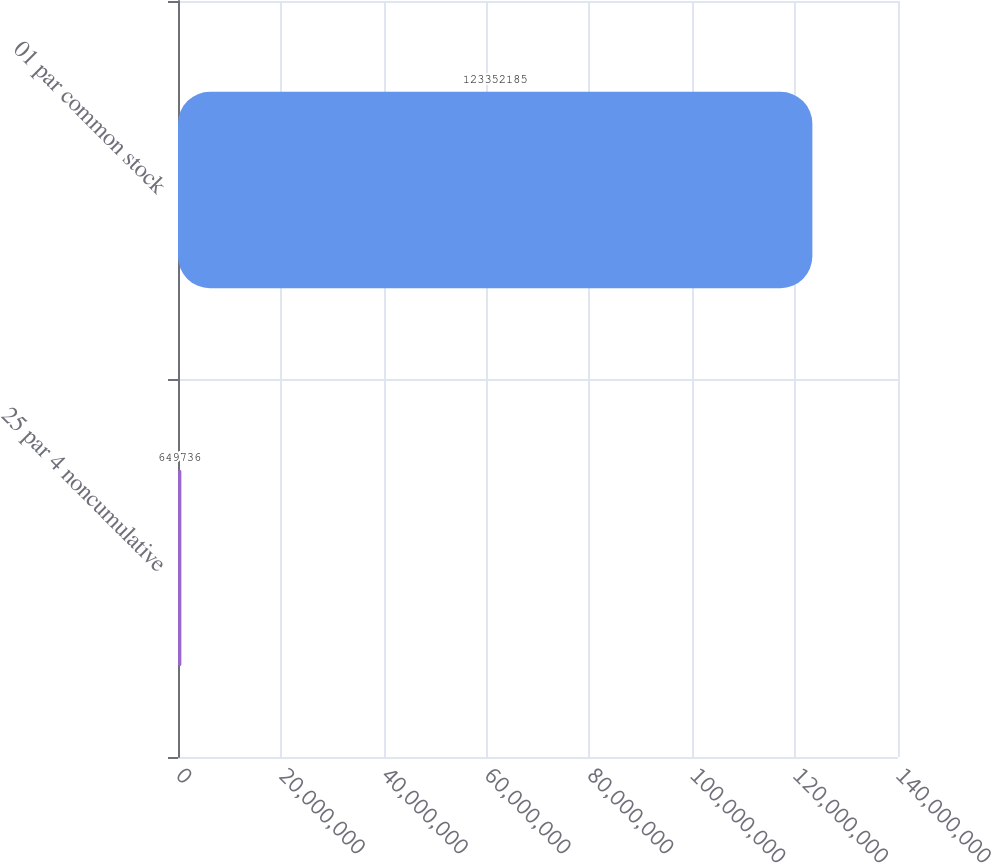Convert chart to OTSL. <chart><loc_0><loc_0><loc_500><loc_500><bar_chart><fcel>25 par 4 noncumulative<fcel>01 par common stock<nl><fcel>649736<fcel>1.23352e+08<nl></chart> 